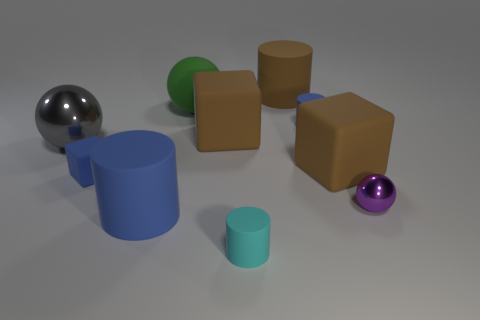Subtract all blue cylinders. How many were subtracted if there are1blue cylinders left? 1 Subtract all large blocks. How many blocks are left? 1 Subtract all brown cylinders. How many cylinders are left? 3 Subtract all cylinders. How many objects are left? 6 Subtract 1 cylinders. How many cylinders are left? 3 Subtract all gray balls. Subtract all purple cubes. How many balls are left? 2 Subtract all purple spheres. How many green cylinders are left? 0 Subtract all tiny cyan rubber objects. Subtract all small gray shiny blocks. How many objects are left? 9 Add 2 gray balls. How many gray balls are left? 3 Add 5 yellow metallic cubes. How many yellow metallic cubes exist? 5 